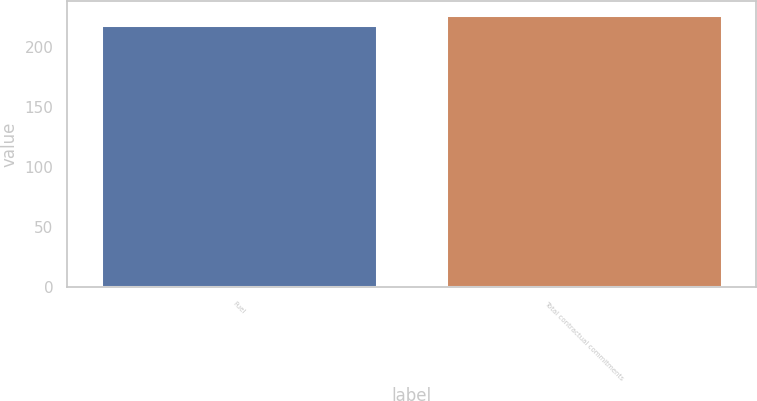Convert chart to OTSL. <chart><loc_0><loc_0><loc_500><loc_500><bar_chart><fcel>Fuel<fcel>Total contractual commitments<nl><fcel>218.1<fcel>227<nl></chart> 